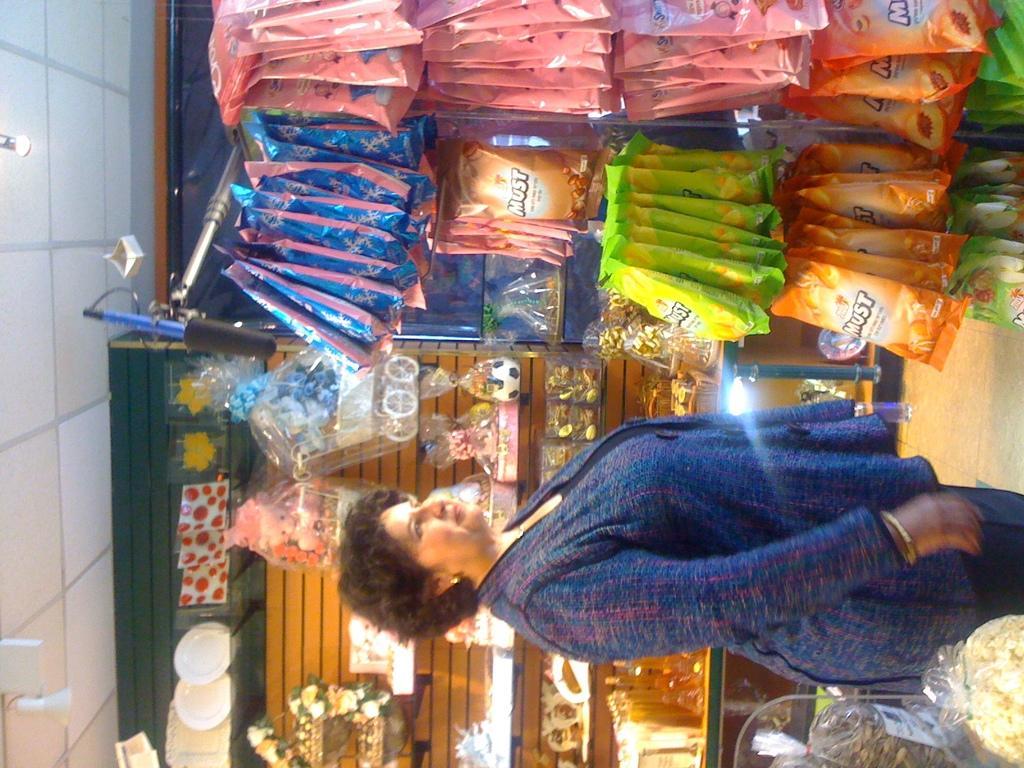Could you give a brief overview of what you see in this image? This picture is in leftward direction. At the bottom, there is a woman wearing blue dress. Beside her, there are racks full of objects. On the top, there are food packets hanged to the rod. Towards the left, there is a ceiling with lights. 